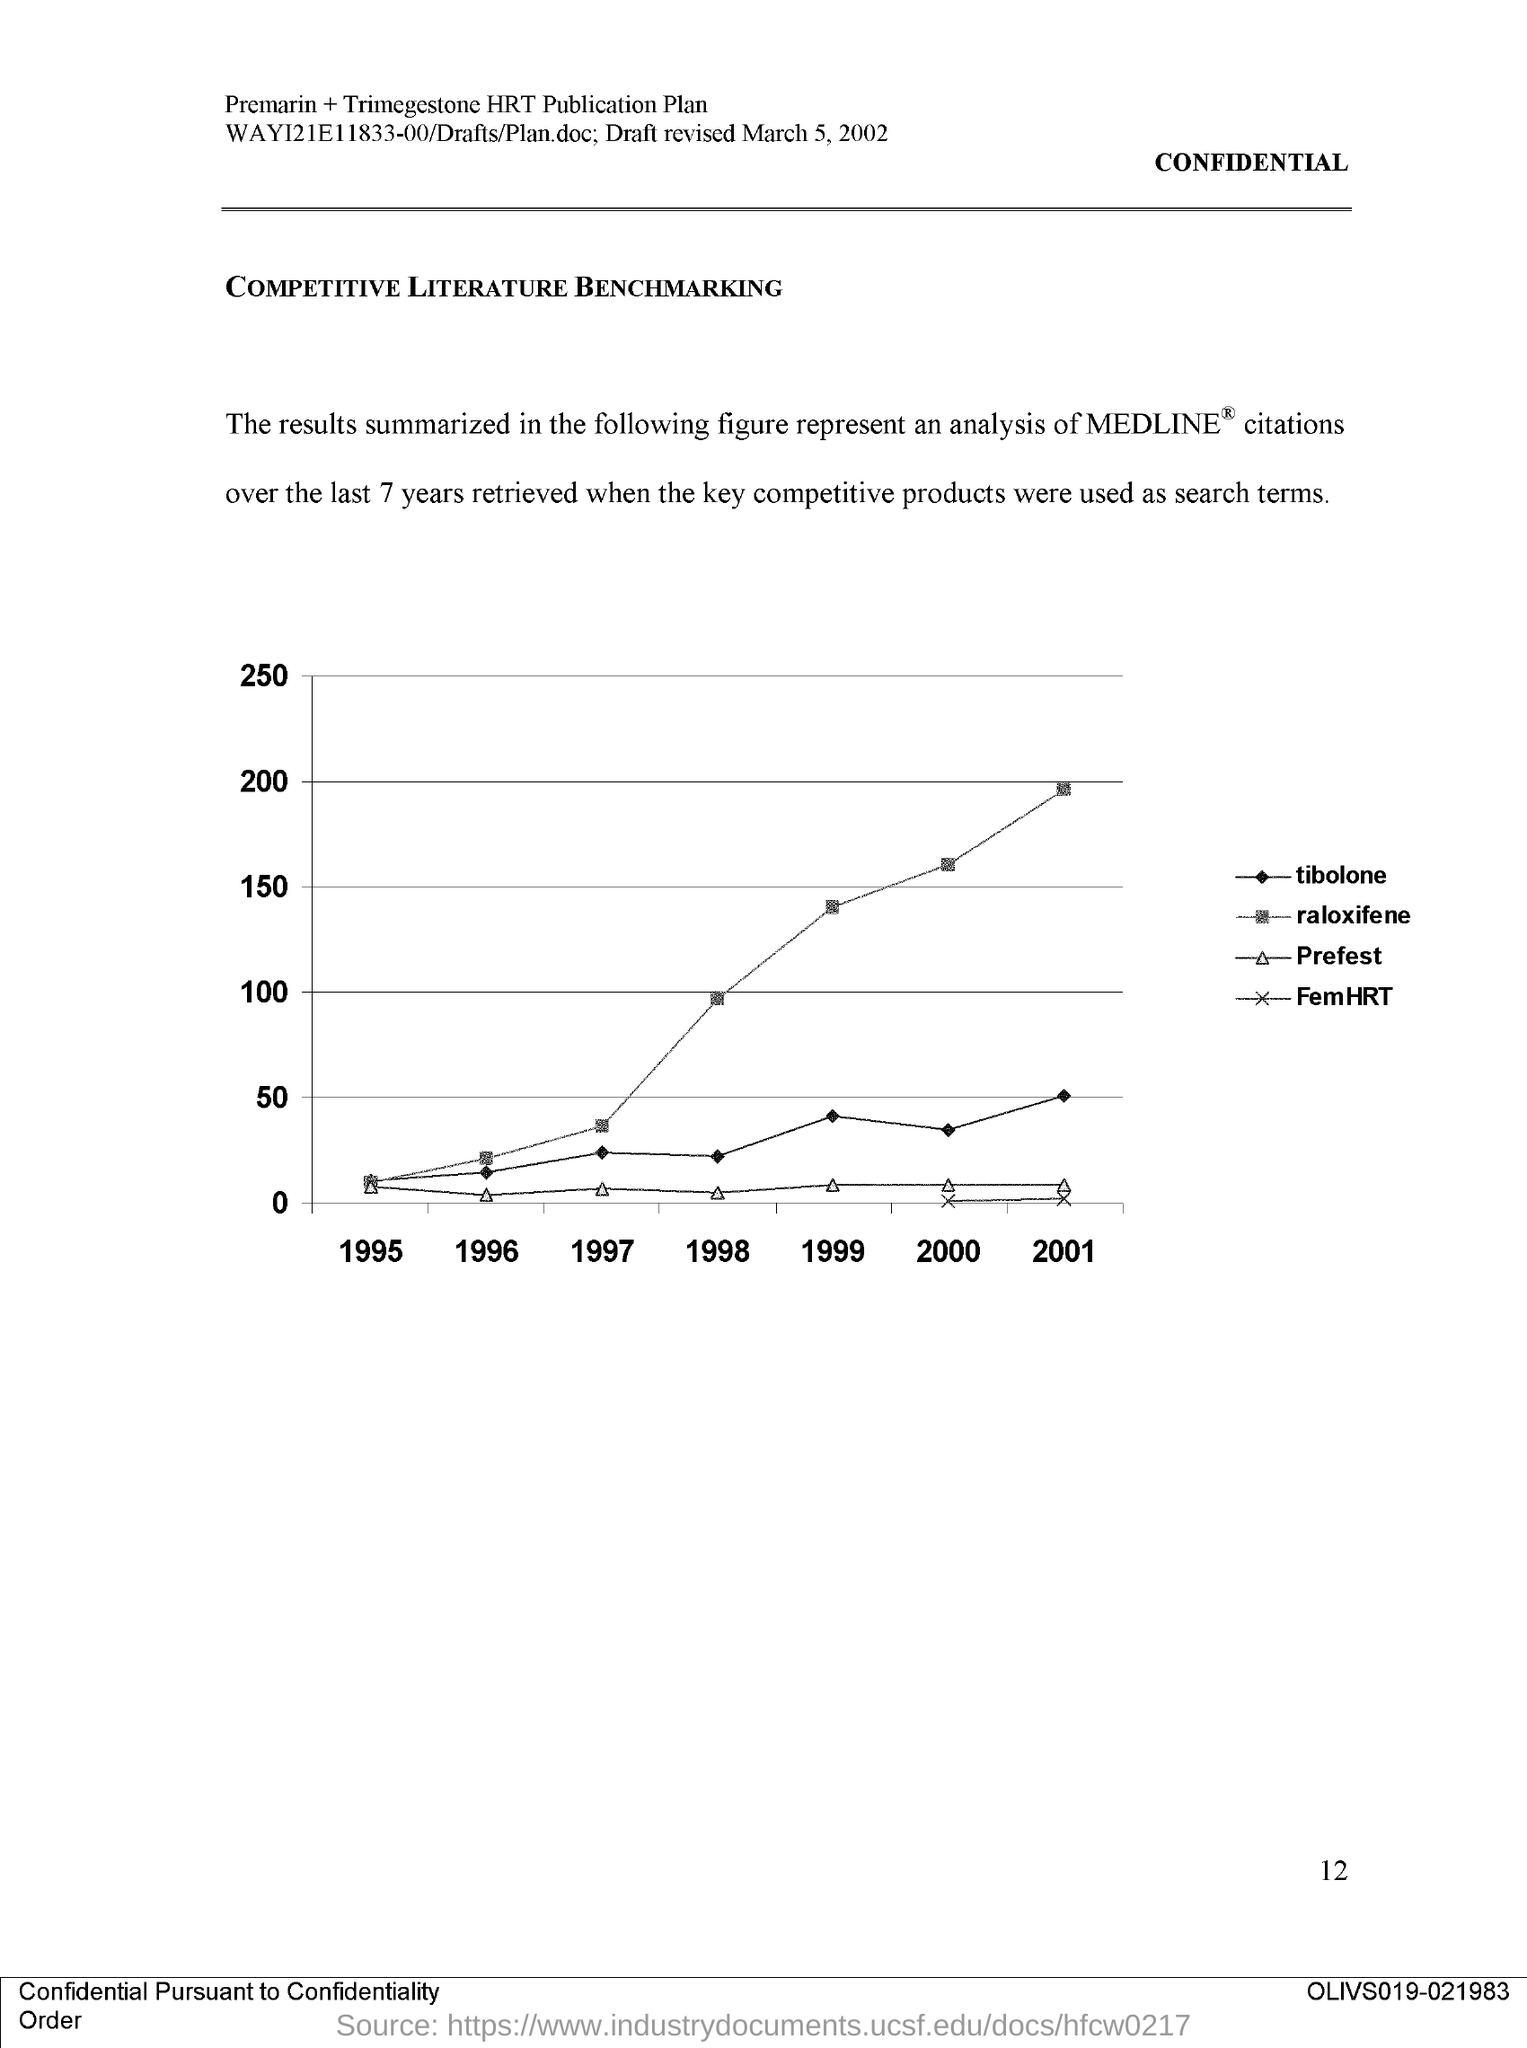What is the document title?
Provide a short and direct response. COMPETITIVE LITERATURE BENCHMARKING. What is the page number on this document?
Your answer should be compact. 12. 